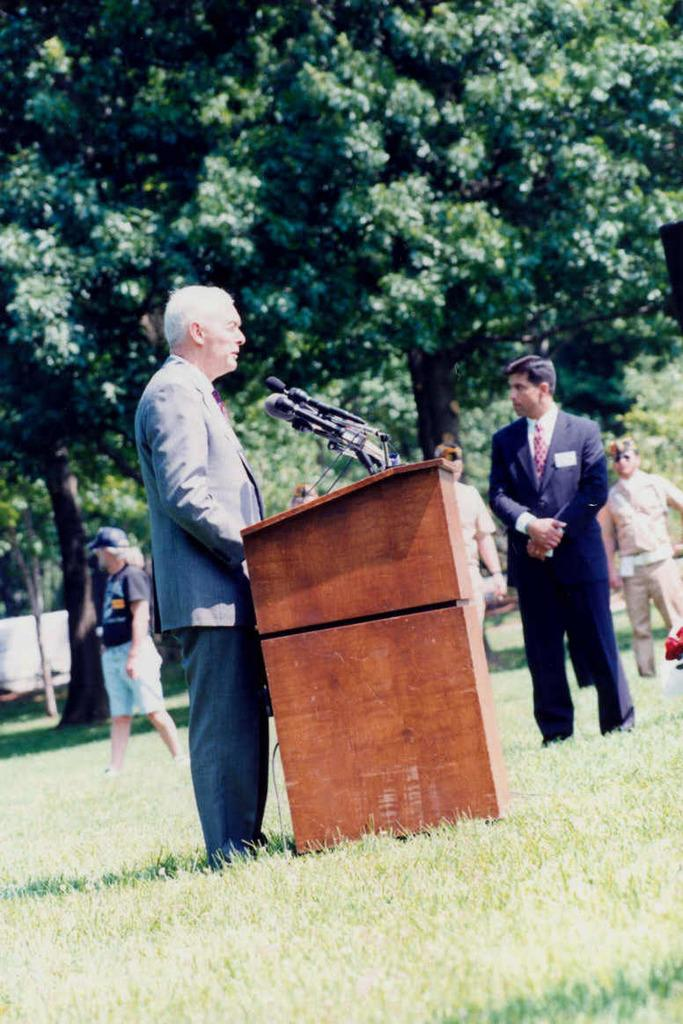What is the main subject of the image? There is a person standing in the center of the image. What object is present near the person? There is a podium in the image. What type of ground is visible at the bottom of the image? There is grass at the bottom of the image. What can be seen in the distance in the image? There are trees in the background of the image. What type of discussion is taking place between the person and the trees in the image? There is no discussion taking place between the person and the trees in the image, as trees are not capable of engaging in discussions. 